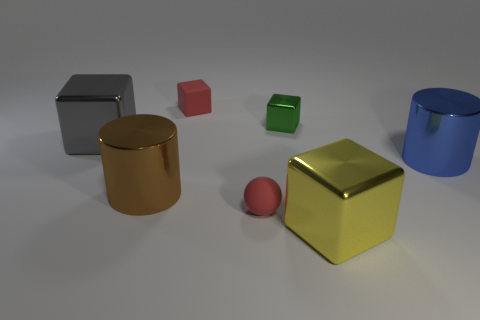Subtract all rubber blocks. How many blocks are left? 3 Add 3 big blue things. How many objects exist? 10 Subtract all cylinders. How many objects are left? 5 Subtract all cylinders. Subtract all tiny rubber cubes. How many objects are left? 4 Add 1 large gray metal cubes. How many large gray metal cubes are left? 2 Add 1 red rubber objects. How many red rubber objects exist? 3 Subtract all green blocks. How many blocks are left? 3 Subtract 1 yellow cubes. How many objects are left? 6 Subtract 2 cylinders. How many cylinders are left? 0 Subtract all red blocks. Subtract all yellow spheres. How many blocks are left? 3 